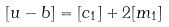Convert formula to latex. <formula><loc_0><loc_0><loc_500><loc_500>[ u - b ] = [ c _ { 1 } ] + 2 [ m _ { 1 } ]</formula> 